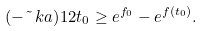<formula> <loc_0><loc_0><loc_500><loc_500>( - \tilde { \ } k a ) ^ { } { 1 } 2 t _ { 0 } \geq e ^ { f _ { 0 } } - e ^ { f ( t _ { 0 } ) } .</formula> 